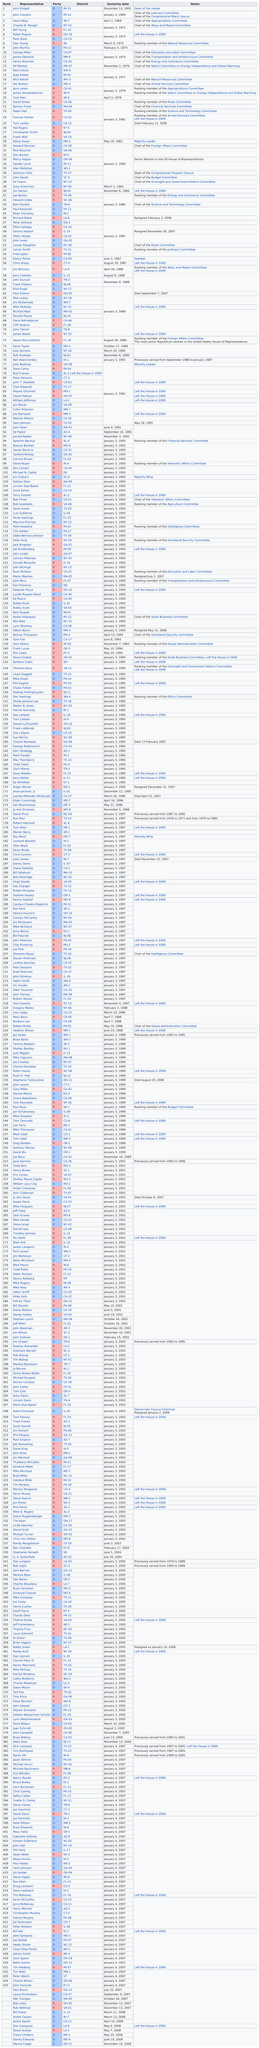Outline some significant characteristics in this image. Marcy Kaptur, the only woman ranked in the top 50 representatives, was a prominent figure in Congress, Four representatives shared a seniority date in 1977. David Dreier was the representative after Tom Petri. Yes, each congressman has a party listed. Gregory Meeks is the person listed after rank number 218. 